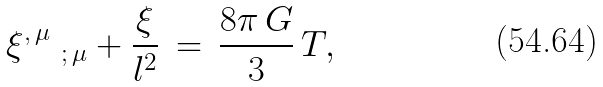<formula> <loc_0><loc_0><loc_500><loc_500>\xi ^ { , \, \mu } \, _ { \, ; \, \mu } + \frac { \xi } { l ^ { 2 } } \, = \, \frac { 8 \pi \, G } { 3 } \, T ,</formula> 